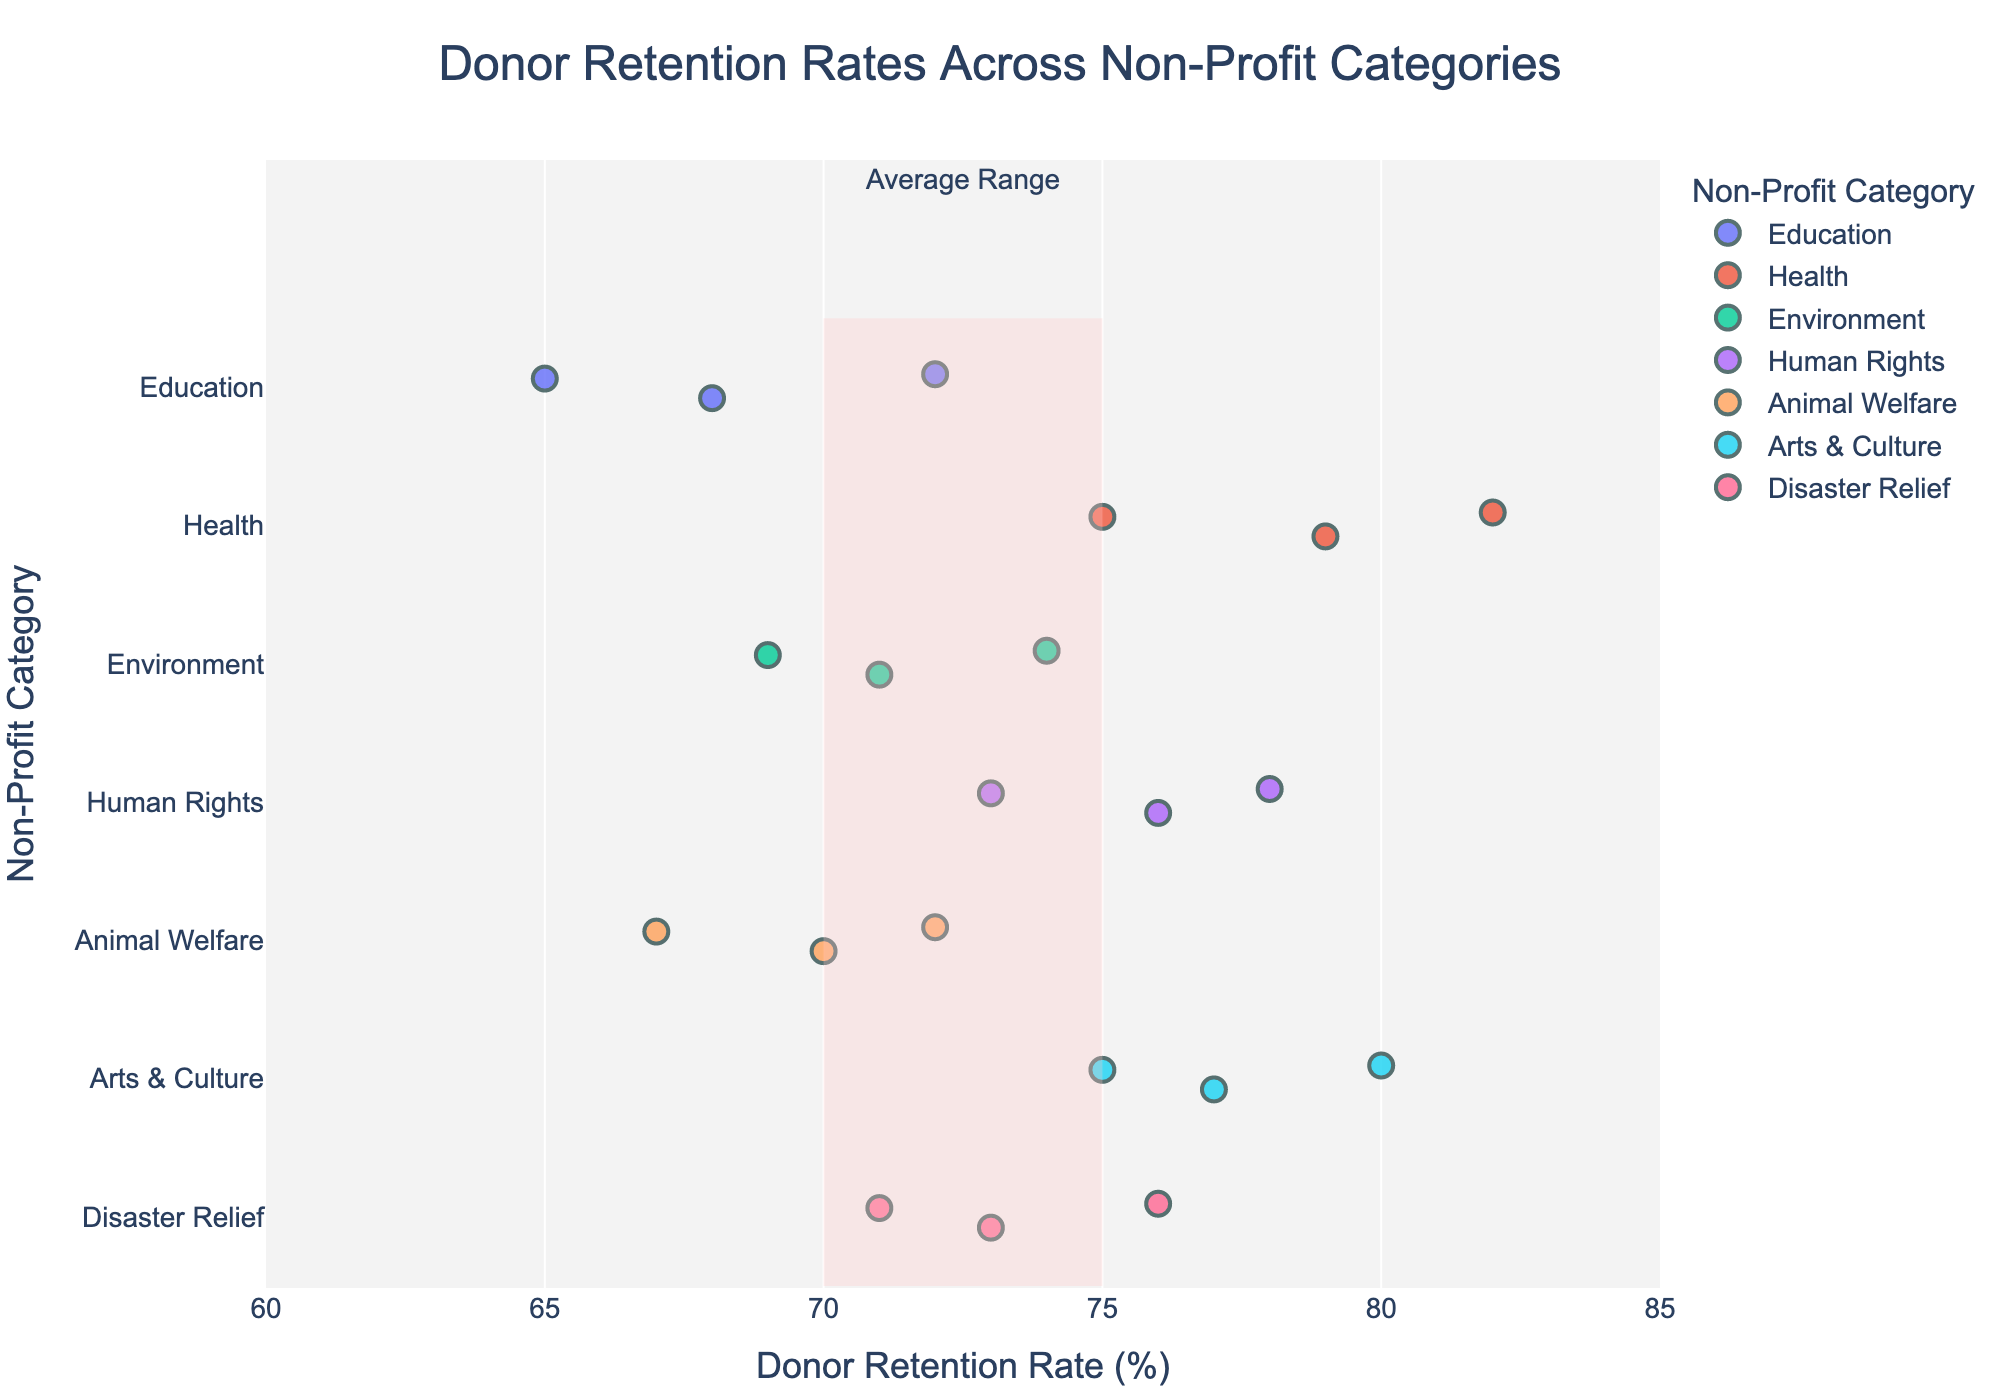What is the title of the plot? The title of the plot is displayed at the top of the figure and usually describes the content of the plot.
Answer: Donor Retention Rates Across Non-Profit Categories What is the non-profit category with the highest average donor retention rate? Look for the category with the highest concentration of data points towards the right side of the plot. The 'Arts & Culture' category has its points (77, 80, 75) clustered high.
Answer: Arts & Culture Which organization has the lowest donor retention rate in the 'Education' category? Identify the points within the 'Education' category and compare their retention rates. Teach For America: 68, Khan Academy: 72, DonorsChoose: 65.
Answer: DonorsChoose What is the range of donor retention rates for the 'Health' category? Examine the 'Health' category on the Y-axis and note the minimum and maximum retention rates. The points are 75, 79, and 82.
Answer: 75 to 82 How many non-profit organizations are listed in the 'Human Rights' category? Count the number of points in the 'Human Rights' category strip. The points represent three organizations: Amnesty International, Human Rights Watch, and ACLU.
Answer: 3 Which organization has the highest donor retention rate in the entire dataset? Check all data points across categories and pinpoint the one with the highest retention rate. St. Jude Children's Research Hospital has the highest rate of 82.
Answer: St. Jude Children's Research Hospital What is the average donor retention rate for the 'Animal Welfare' category? Calculate the average of the retention rates for ASPCA, Humane Society, and Best Friends Animal Society which are 70, 72, and 67, respectively. Average=(70+72+67)/3 = 69.67.
Answer: 69.67 Is the average donor retention rate for the 'Disaster Relief' category within the highlighted average range? Check the 'Disaster Relief' category points (UNICEF: 76, Save the Children: 73, Direct Relief: 71) against the highlighted average range (70 to 75). Average=(76+73+71)/3=73.33 which is within 70 and 75.
Answer: Yes Which non-profit category has data points spread across the entire average range (70-75%)? Identify the category with points fully within the highlighted range. 'Disaster Relief' has 71, 73, and 76 with two points between 70 and 75.
Answer: Disaster Relief Which category has the most variability in donor retention rates? Look for the category with the widest spread between its minimum and maximum data points. The 'Health' category ranges from 75 to 82, making it the most variable.
Answer: Health 